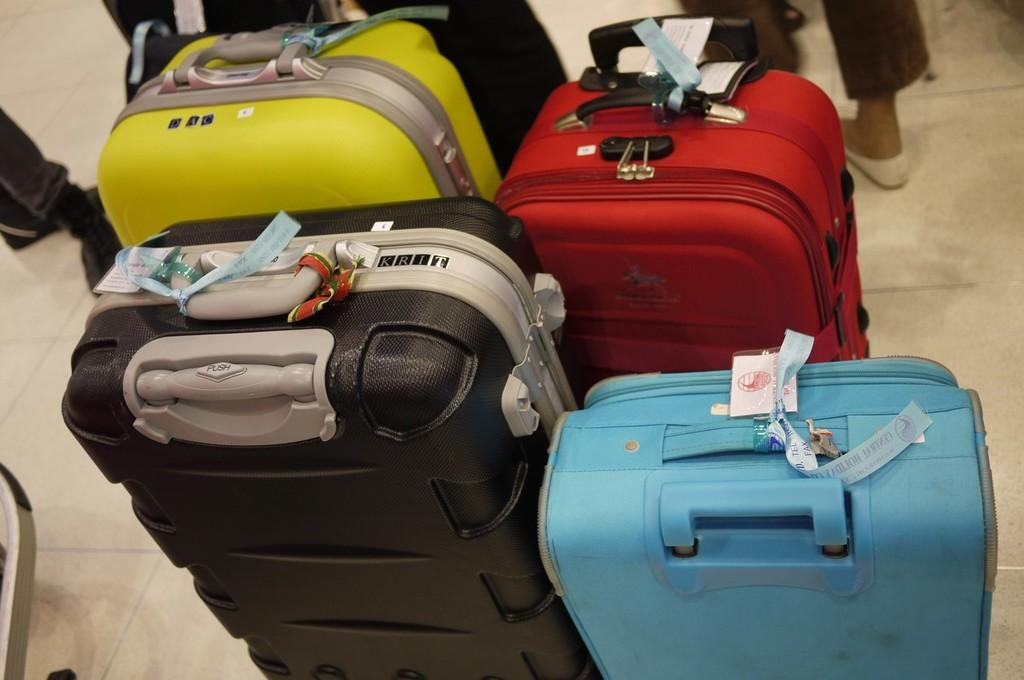How many suitcases are in the image? There are four colored suitcases in the image. What can be found on the suitcases? The suitcases have tags on them. Where are the suitcases located? The suitcases are placed on the floor. Can you describe any other elements in the image? Some persons' legs are visible in the image. What type of dirt can be seen on the suitcases in the image? There is no dirt visible on the suitcases in the image. How many cats are present in the image? There are no cats present in the image. 